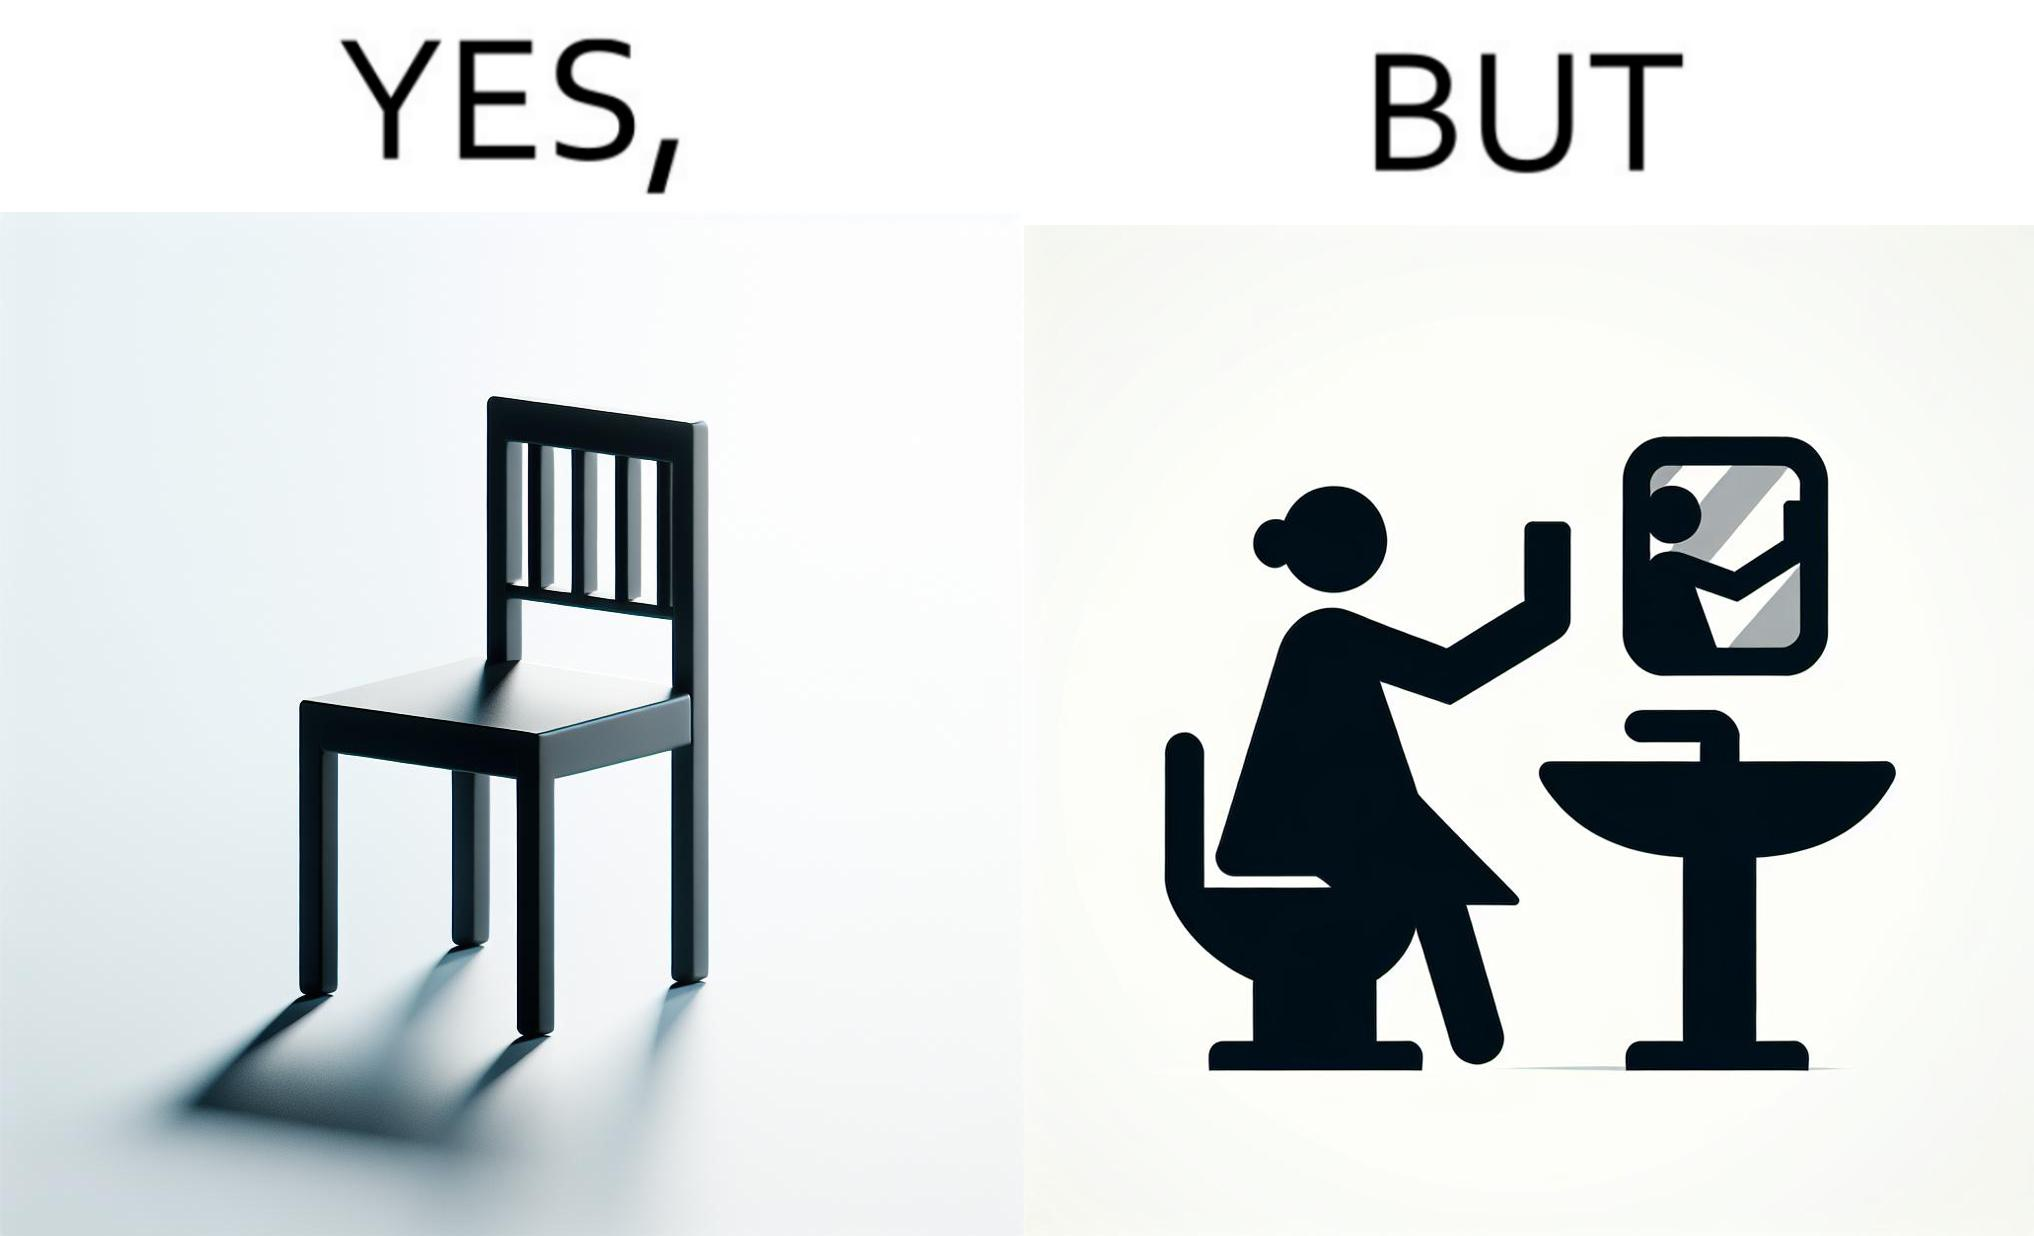Describe the satirical element in this image. The image is ironical, as a woman is sitting by the sink taking a selfie using a mirror, while not using a chair that is actually meant for sitting. 